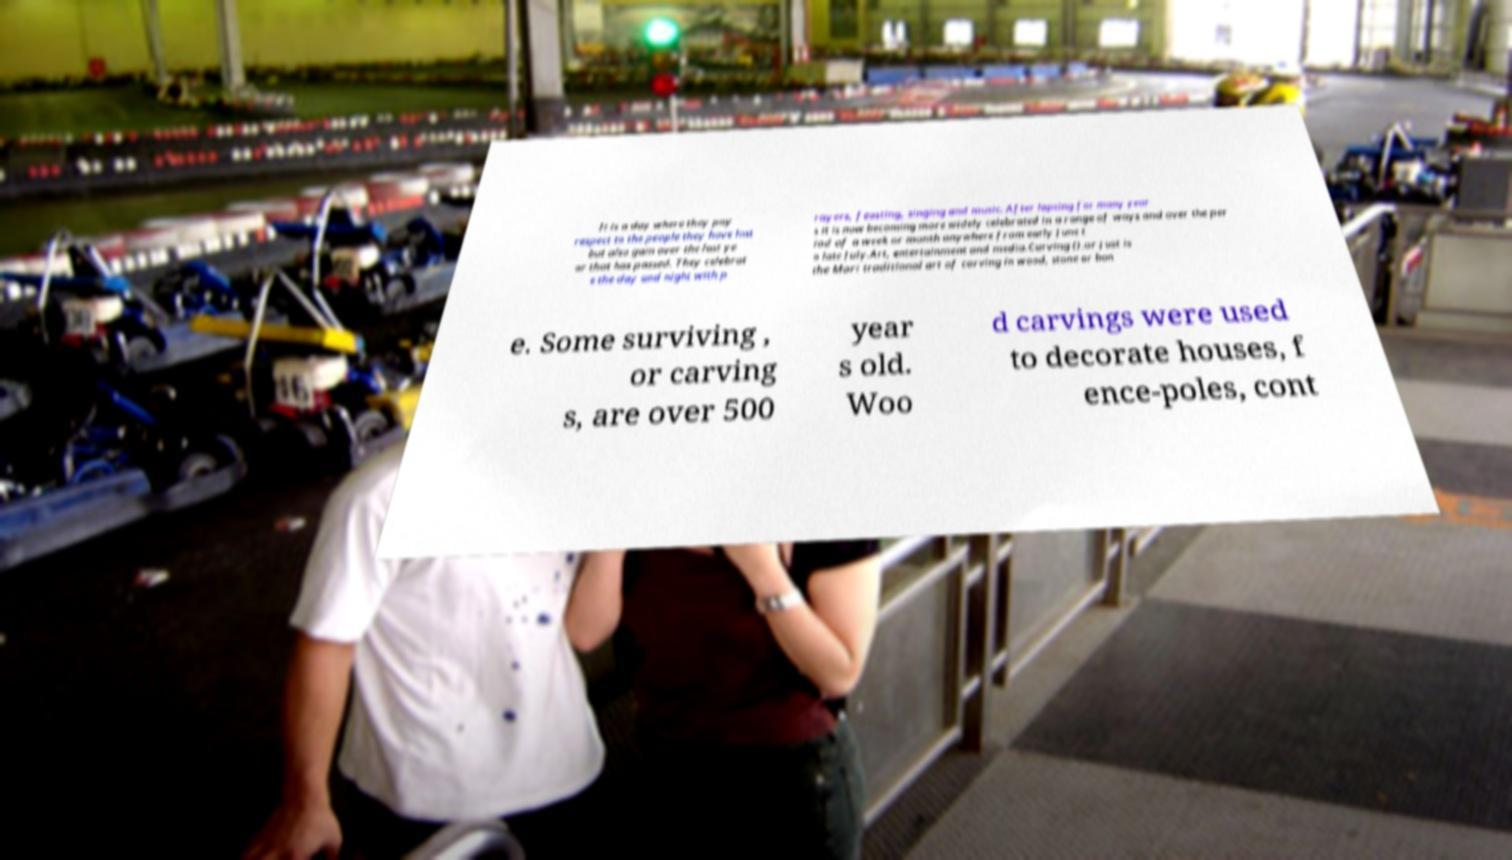Can you accurately transcribe the text from the provided image for me? It is a day where they pay respect to the people they have lost but also gain over the last ye ar that has passed. They celebrat e the day and night with p rayers, feasting, singing and music. After lapsing for many year s it is now becoming more widely celebrated in a range of ways and over the per iod of a week or month anywhere from early June t o late July.Art, entertainment and media.Carving ().or just is the Mori traditional art of carving in wood, stone or bon e. Some surviving , or carving s, are over 500 year s old. Woo d carvings were used to decorate houses, f ence-poles, cont 